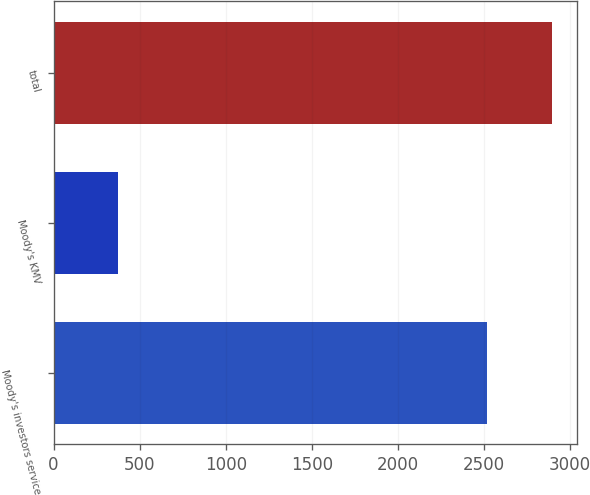Convert chart. <chart><loc_0><loc_0><loc_500><loc_500><bar_chart><fcel>Moody's investors service<fcel>Moody's KMV<fcel>total<nl><fcel>2519<fcel>377<fcel>2896<nl></chart> 